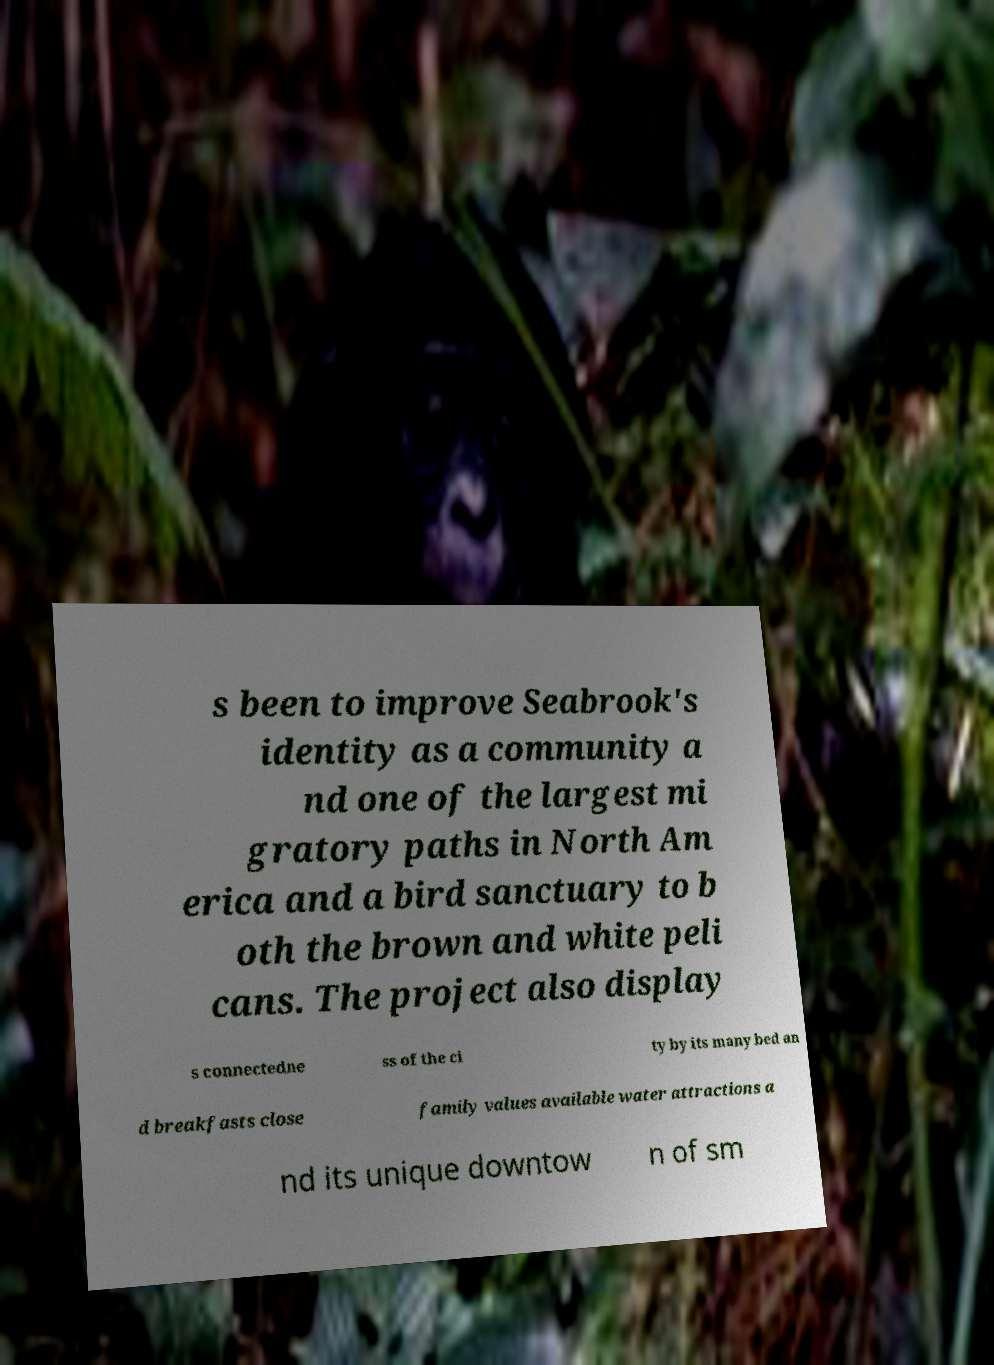I need the written content from this picture converted into text. Can you do that? s been to improve Seabrook's identity as a community a nd one of the largest mi gratory paths in North Am erica and a bird sanctuary to b oth the brown and white peli cans. The project also display s connectedne ss of the ci ty by its many bed an d breakfasts close family values available water attractions a nd its unique downtow n of sm 